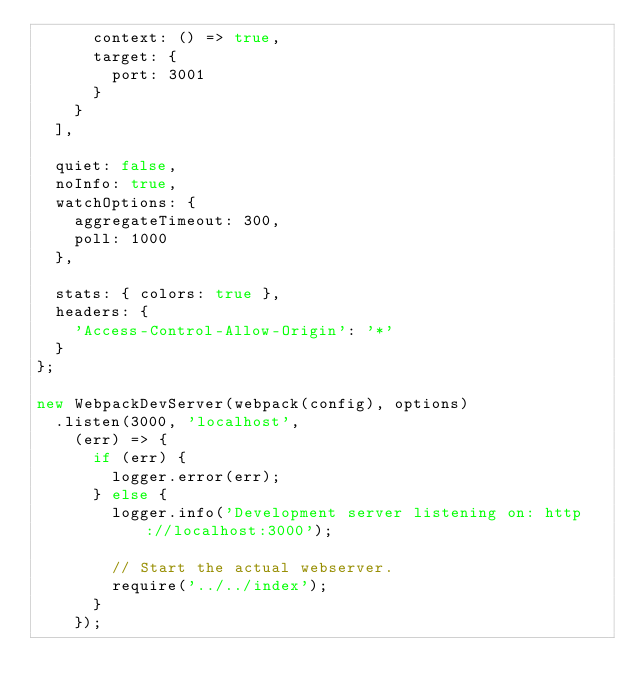Convert code to text. <code><loc_0><loc_0><loc_500><loc_500><_JavaScript_>      context: () => true,
      target: {
        port: 3001
      }
    }
  ],

  quiet: false,
  noInfo: true,
  watchOptions: {
    aggregateTimeout: 300,
    poll: 1000
  },

  stats: { colors: true },
  headers: { 
    'Access-Control-Allow-Origin': '*' 
  }
};

new WebpackDevServer(webpack(config), options)
  .listen(3000, 'localhost',
    (err) => {
      if (err) {
        logger.error(err);
      } else {
        logger.info('Development server listening on: http://localhost:3000');

        // Start the actual webserver.
        require('../../index');
      }
    });
</code> 